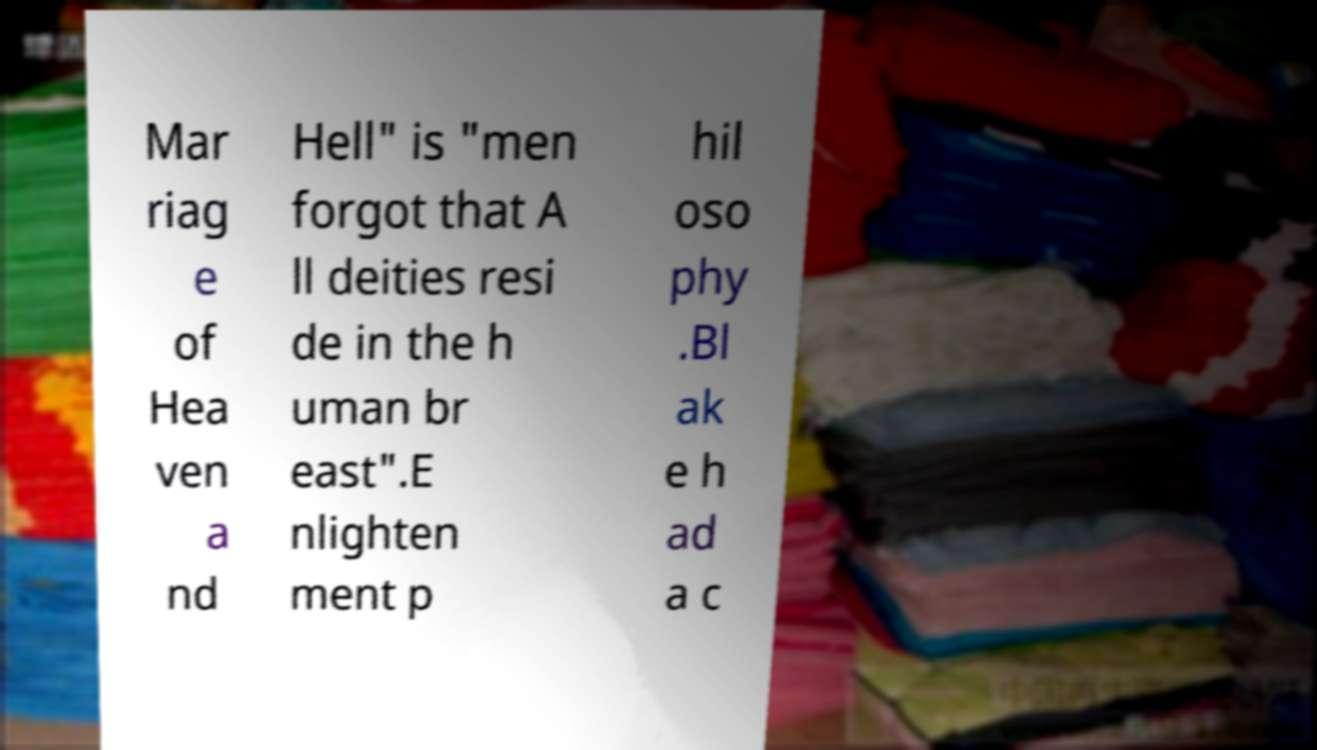Can you read and provide the text displayed in the image?This photo seems to have some interesting text. Can you extract and type it out for me? Mar riag e of Hea ven a nd Hell" is "men forgot that A ll deities resi de in the h uman br east".E nlighten ment p hil oso phy .Bl ak e h ad a c 